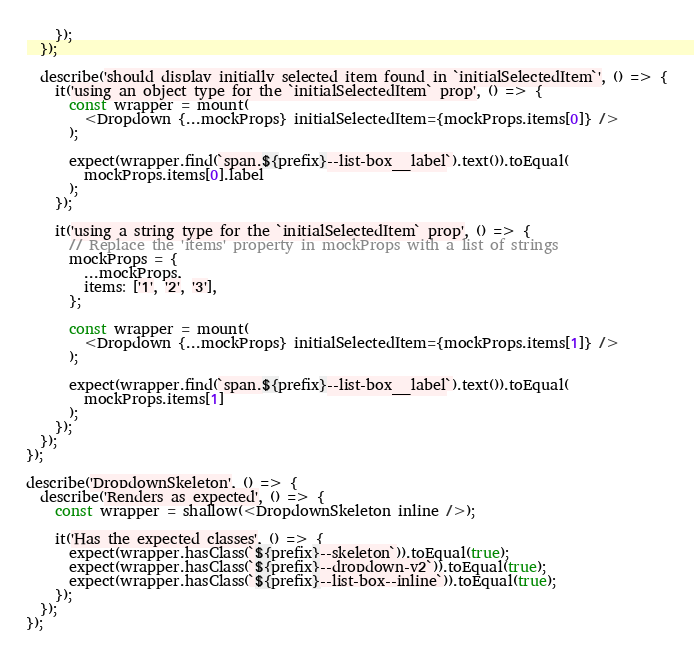Convert code to text. <code><loc_0><loc_0><loc_500><loc_500><_JavaScript_>    });
  });

  describe('should display initially selected item found in `initialSelectedItem`', () => {
    it('using an object type for the `initialSelectedItem` prop', () => {
      const wrapper = mount(
        <Dropdown {...mockProps} initialSelectedItem={mockProps.items[0]} />
      );

      expect(wrapper.find(`span.${prefix}--list-box__label`).text()).toEqual(
        mockProps.items[0].label
      );
    });

    it('using a string type for the `initialSelectedItem` prop', () => {
      // Replace the 'items' property in mockProps with a list of strings
      mockProps = {
        ...mockProps,
        items: ['1', '2', '3'],
      };

      const wrapper = mount(
        <Dropdown {...mockProps} initialSelectedItem={mockProps.items[1]} />
      );

      expect(wrapper.find(`span.${prefix}--list-box__label`).text()).toEqual(
        mockProps.items[1]
      );
    });
  });
});

describe('DropdownSkeleton', () => {
  describe('Renders as expected', () => {
    const wrapper = shallow(<DropdownSkeleton inline />);

    it('Has the expected classes', () => {
      expect(wrapper.hasClass(`${prefix}--skeleton`)).toEqual(true);
      expect(wrapper.hasClass(`${prefix}--dropdown-v2`)).toEqual(true);
      expect(wrapper.hasClass(`${prefix}--list-box--inline`)).toEqual(true);
    });
  });
});
</code> 